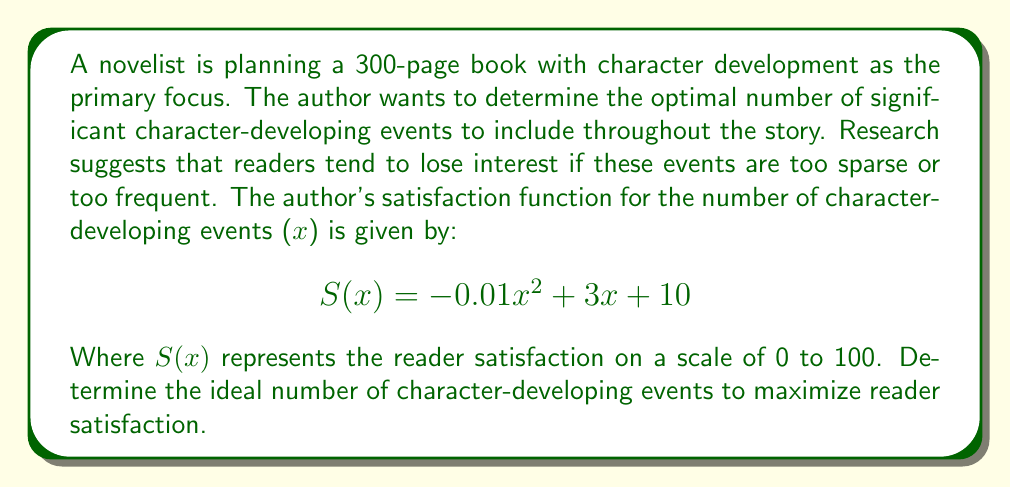Teach me how to tackle this problem. To solve this optimization problem, we need to find the maximum value of the satisfaction function S(x). This can be done by following these steps:

1. The satisfaction function is a quadratic function in the form of $ax^2 + bx + c$, where:
   $a = -0.01$
   $b = 3$
   $c = 10$

2. For a quadratic function, the maximum (or minimum) occurs at the vertex of the parabola. The x-coordinate of the vertex can be found using the formula:

   $$x = -\frac{b}{2a}$$

3. Substituting our values:

   $$x = -\frac{3}{2(-0.01)} = \frac{3}{0.02} = 150$$

4. To verify this is a maximum (not a minimum), we can check that $a < 0$, which is true in this case.

5. Since we're dealing with character-developing events, we need to round this to the nearest whole number, which is still 150.

6. We can calculate the maximum satisfaction by plugging x = 150 into our original function:

   $$S(150) = -0.01(150)^2 + 3(150) + 10$$
   $$= -225 + 450 + 10$$
   $$= 235$$

7. However, since our scale is from 0 to 100, we'll cap this at 100.

Therefore, the ideal number of character-developing events is 150, which will result in maximum reader satisfaction.
Answer: The ideal number of character-developing events to maximize reader satisfaction is 150. 